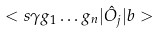Convert formula to latex. <formula><loc_0><loc_0><loc_500><loc_500>< s \gamma g _ { 1 } \dots g _ { n } | \hat { O } _ { j } | b ></formula> 